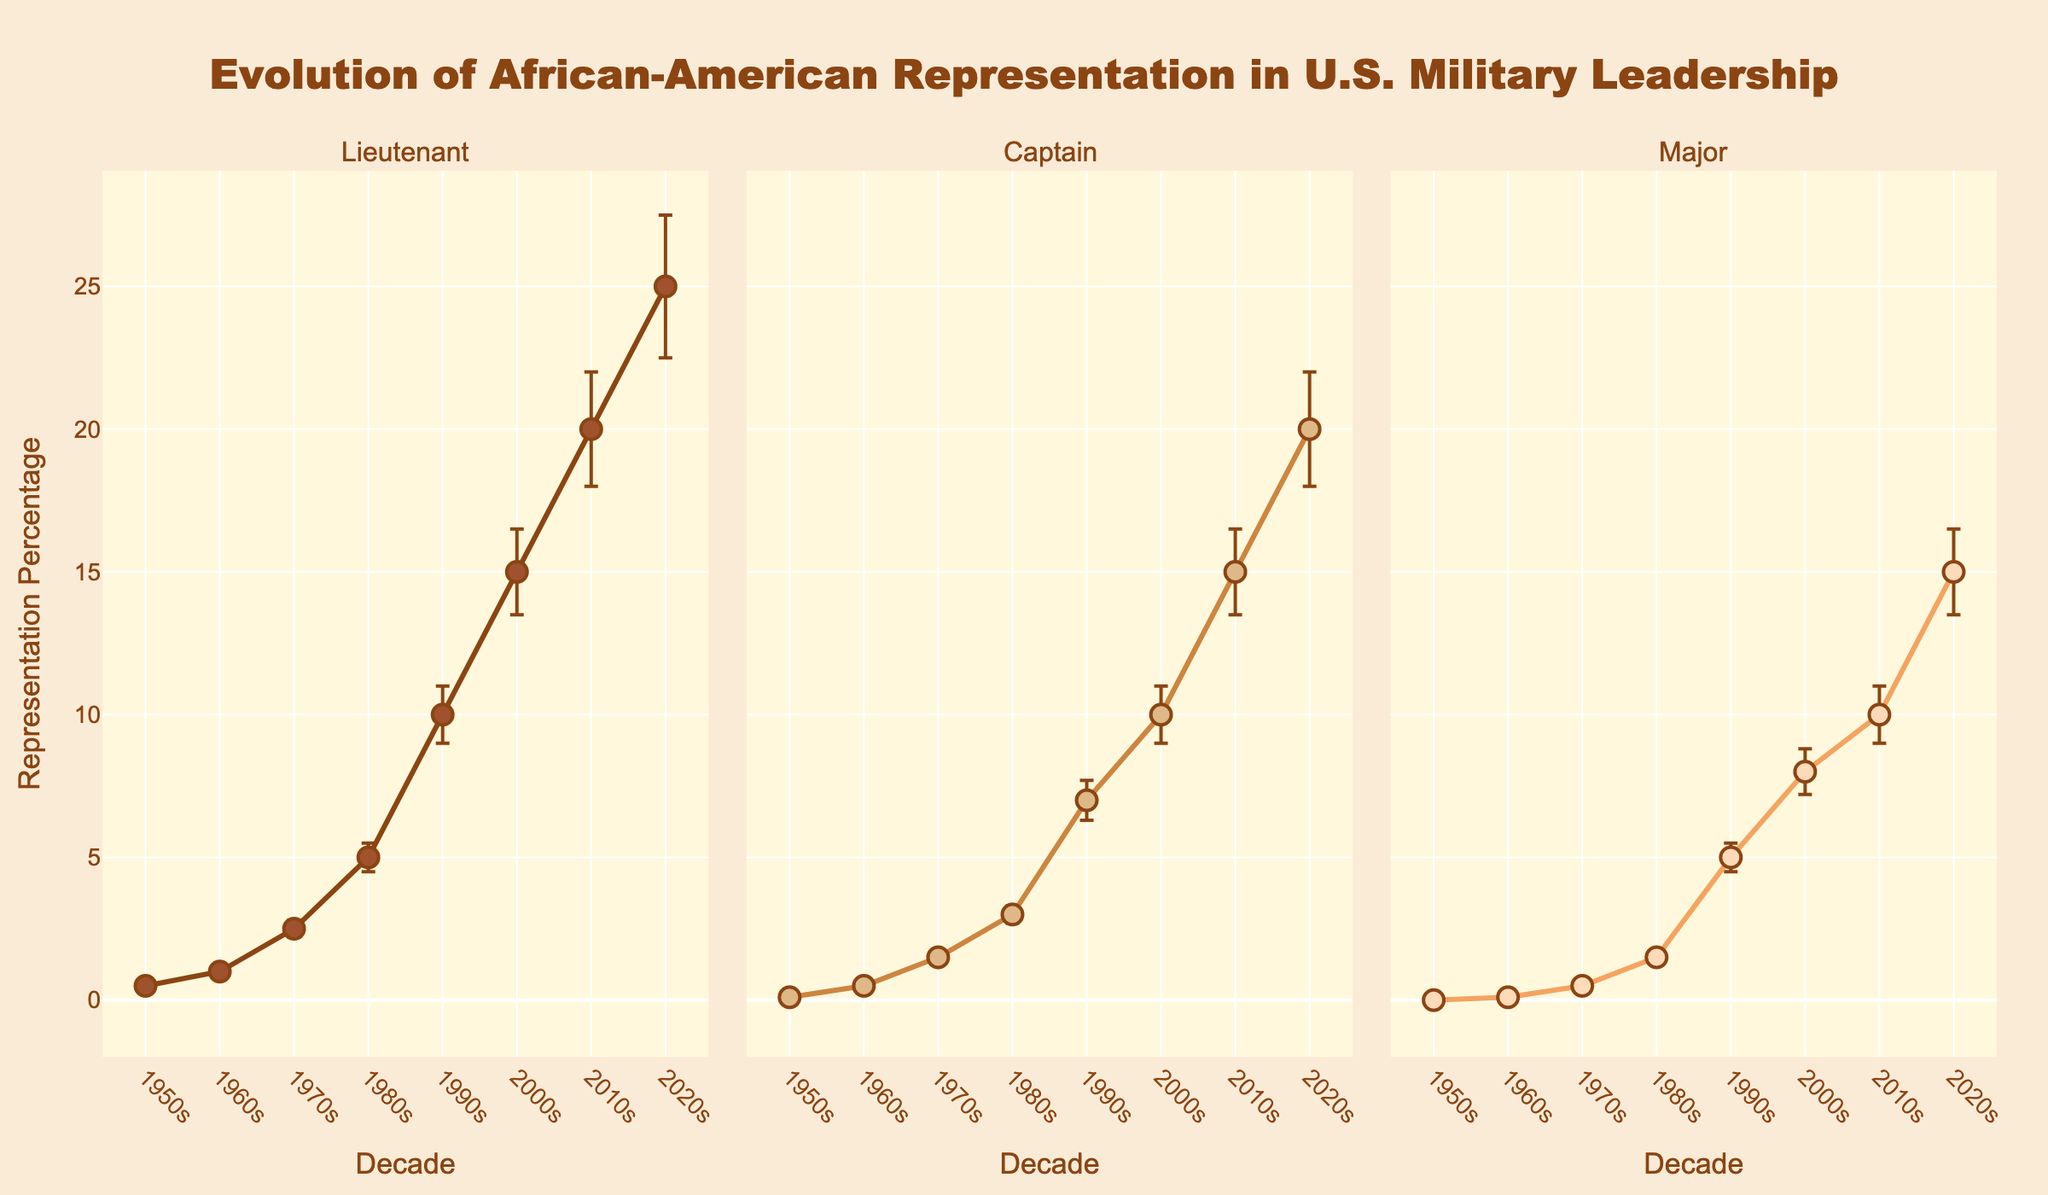How many decades are represented for each rank? For each subplot (Lieutenant, Captain, Major), count the number of x-axis tick marks (each representing a decade). Each rank has decades ranging from 1950s to 2020s, making it 8 decades.
Answer: 8 What is the overall trend of African-American representation in the rank of Lieutenant over time? Observe the line plot for the Lieutenant rank. The Representation Percentage increases steadily from 0.5% in the 1950s to 25% in the 2020s.
Answer: Increasing How do the error bars for Captains in the 1980s compare to those for Majors in the same decade? Look at the length of the error bars in the 1980s subplot for both ranks. Captains have a larger error bar (±0.3) compared to Majors (±0.2).
Answer: Captains' error bars are larger Which decade saw the highest percentage of African-American representation in the rank of Major? Check the highest y-value in the Major subplot. The highest Representation Percentage is 15% in the 2020s.
Answer: 2020s In which rank and decade did African-American representation start appearing above 5% for the first time? Find the first instance where Representation Percentage goes above 5% across all subplots. This occurs for Lieutenants in the 1980s.
Answer: 1980s, Lieutenant Compare the representation percentages for Lieutenants, Captains, and Majors in the 2000s. Which rank has the highest representation, and which has the lowest? Check the 2000s data points in each subplot. Lieutenants have 15%, Captains 10%, and Majors 8%. Lieutenant has the highest, and Major the lowest.
Answer: Highest: Lieutenant, Lowest: Major What is the difference in African-American representation percentages between Captains and Lieutenants in the 2020s? Subtract the Representation Percentage of Captains (20%) from that of Lieutenants (25%) in the 2020s. The difference is 25% - 20% = 5%.
Answer: 5% Describe the variation consistency for Majors across the decades. Are the error bars increasing, decreasing, or consistent? Examine the size of error bars for Majors across all decades. Error bars are small and relatively consistent, increasing slightly over time.
Answer: Consistent How does the representation trend for Captains in the 1970s compare to the 1980s? Observe the line plot for Captains between these decades. In the 1970s, it increases to 1.5%, and in the 1980s, it further increases to 3.0%, showing a consistent upward trend.
Answer: Upward trend 